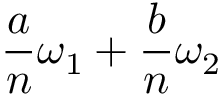Convert formula to latex. <formula><loc_0><loc_0><loc_500><loc_500>{ \frac { a } { n } } \omega _ { 1 } + { \frac { b } { n } } \omega _ { 2 }</formula> 